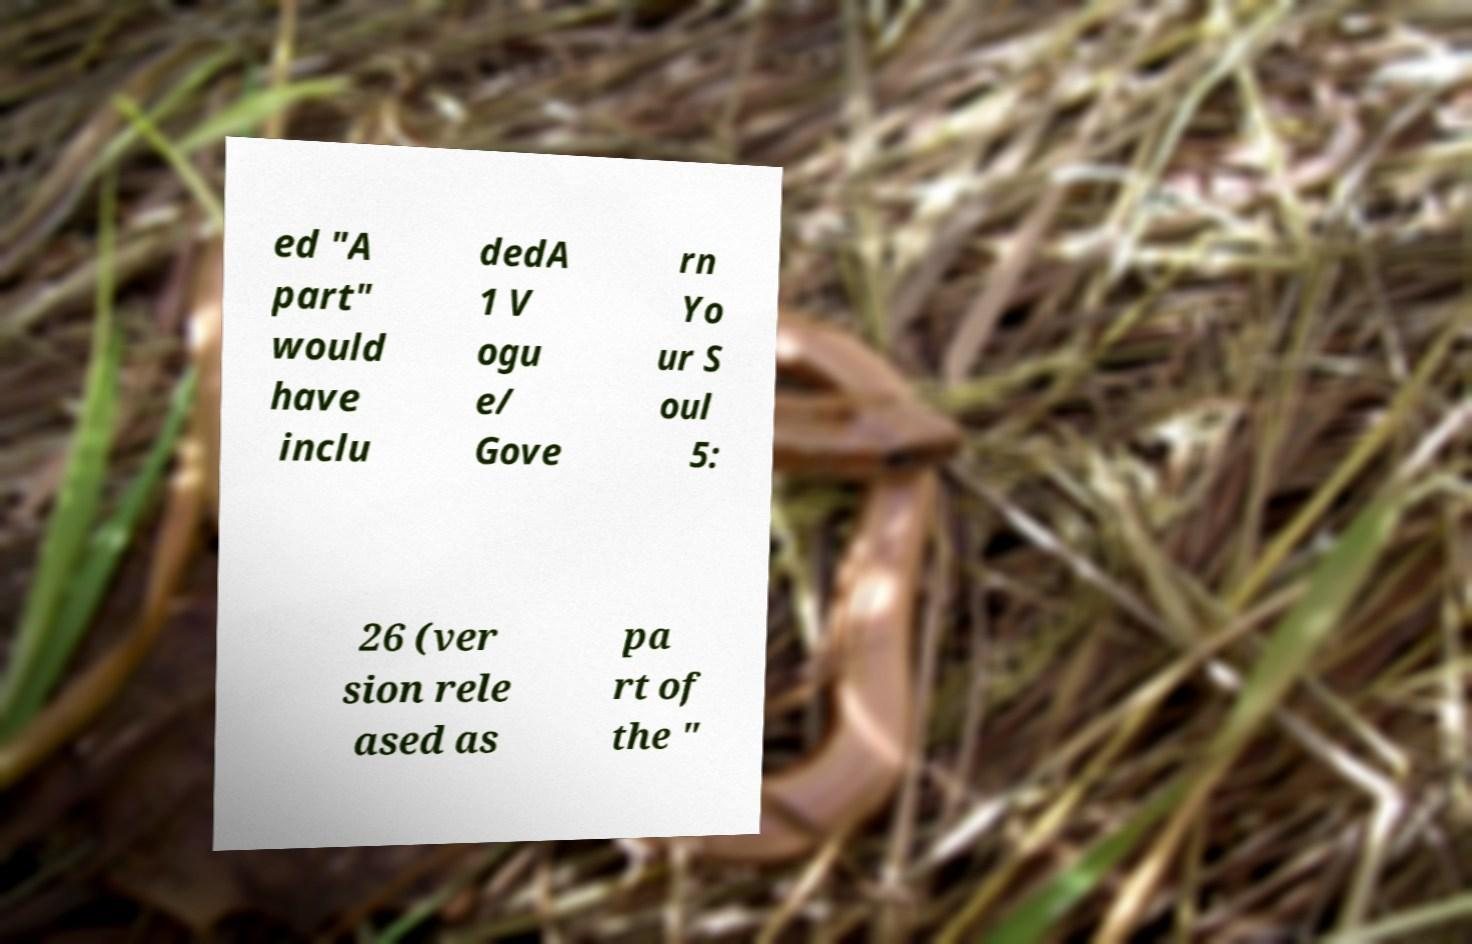Could you extract and type out the text from this image? ed "A part" would have inclu dedA 1 V ogu e/ Gove rn Yo ur S oul 5: 26 (ver sion rele ased as pa rt of the " 